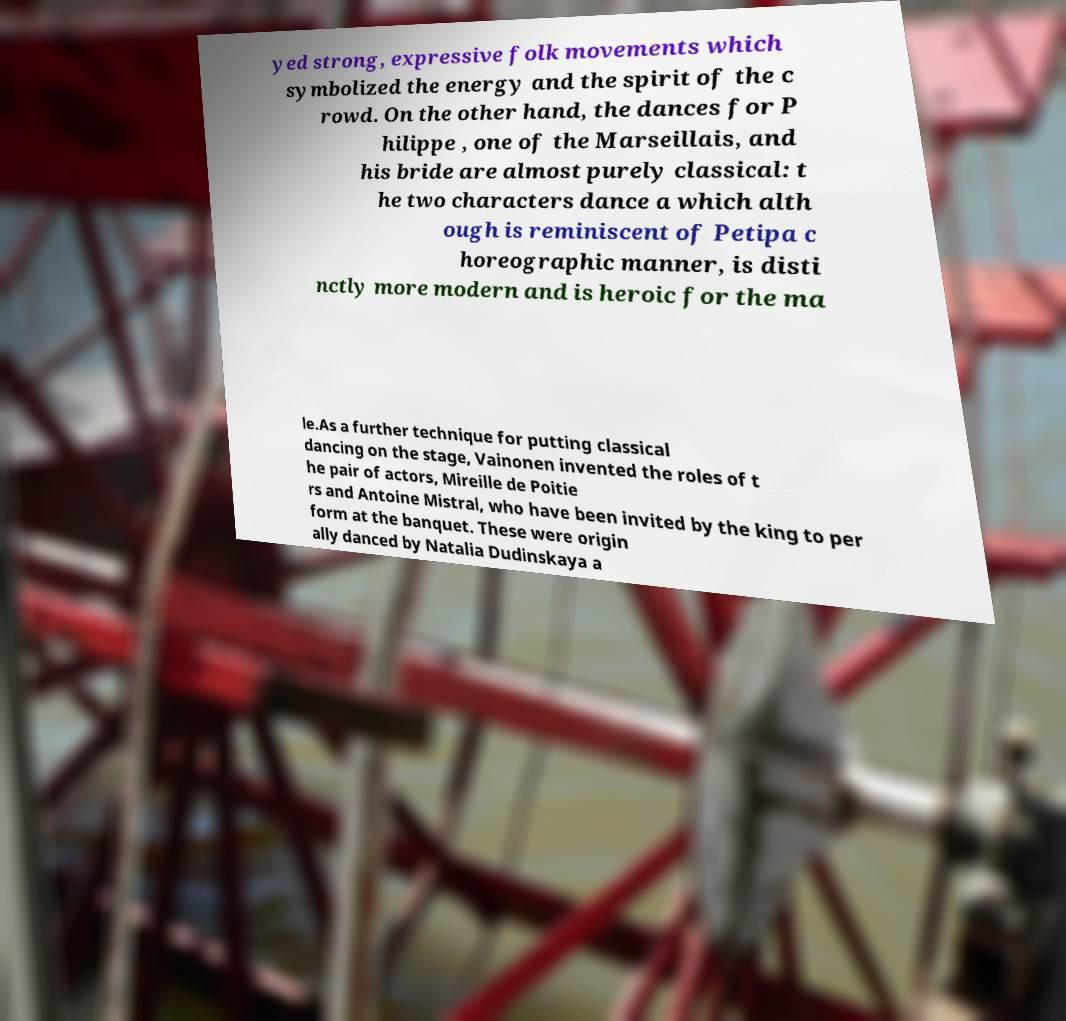Can you read and provide the text displayed in the image?This photo seems to have some interesting text. Can you extract and type it out for me? yed strong, expressive folk movements which symbolized the energy and the spirit of the c rowd. On the other hand, the dances for P hilippe , one of the Marseillais, and his bride are almost purely classical: t he two characters dance a which alth ough is reminiscent of Petipa c horeographic manner, is disti nctly more modern and is heroic for the ma le.As a further technique for putting classical dancing on the stage, Vainonen invented the roles of t he pair of actors, Mireille de Poitie rs and Antoine Mistral, who have been invited by the king to per form at the banquet. These were origin ally danced by Natalia Dudinskaya a 